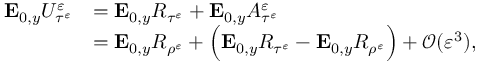Convert formula to latex. <formula><loc_0><loc_0><loc_500><loc_500>\begin{array} { r l } { E _ { 0 , y } U _ { \tau ^ { \varepsilon } } ^ { \varepsilon } } & { = E _ { 0 , y } R _ { \tau ^ { \varepsilon } } + E _ { 0 , y } A _ { \tau ^ { \varepsilon } } ^ { \varepsilon } } \\ & { = E _ { 0 , y } R _ { \rho ^ { \varepsilon } } + \left ( E _ { 0 , y } R _ { \tau ^ { \varepsilon } } - E _ { 0 , y } R _ { \rho ^ { \varepsilon } } \right ) + \mathcal { O } ( \varepsilon ^ { 3 } ) , } \end{array}</formula> 